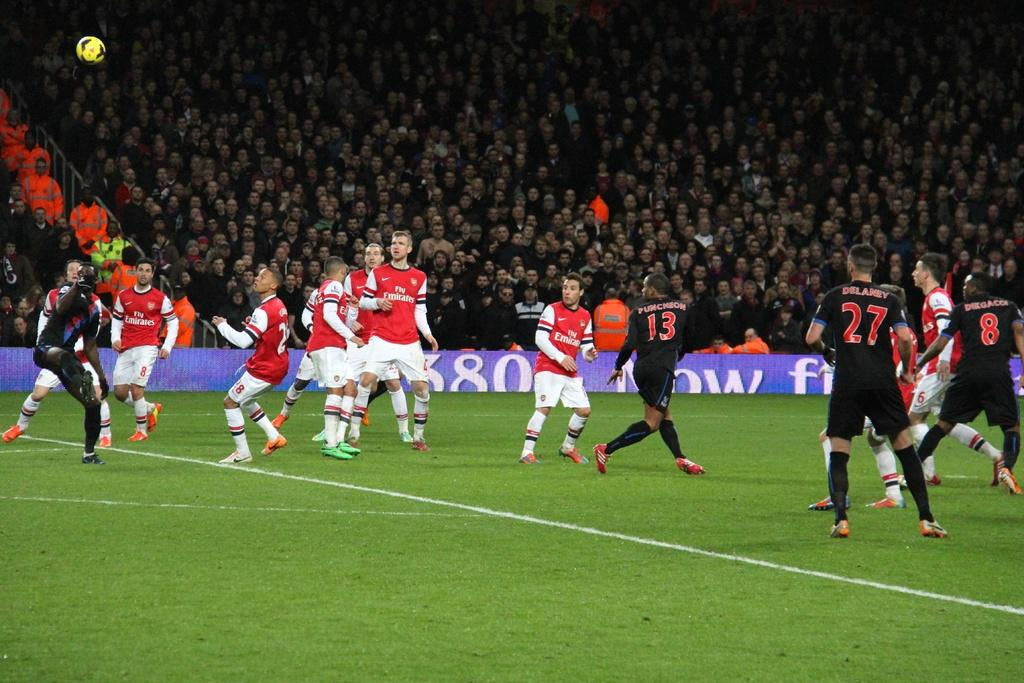What sport are the players engaged in within the image? The players are playing football in the image. Where is the football game taking place? The football game is taking place on a ground. What can be seen in the background of the image? There are people sitting in chairs in the background of the image. How many bridges can be seen in the image? There are no bridges present in the image; it features a football game taking place on a ground. What type of lift is being used by the players during the game? There is no lift being used by the players in the image; they are playing football on a ground. 